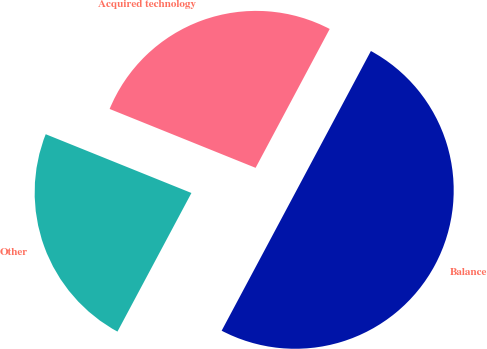<chart> <loc_0><loc_0><loc_500><loc_500><pie_chart><fcel>Acquired technology<fcel>Other<fcel>Balance<nl><fcel>26.7%<fcel>23.3%<fcel>50.0%<nl></chart> 